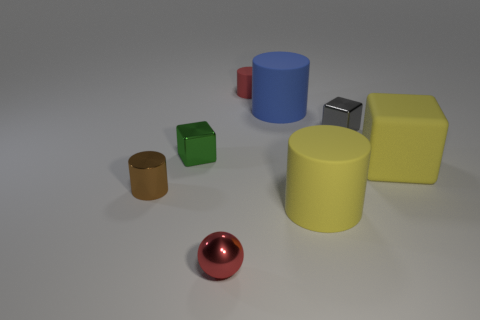Is there anything else that has the same shape as the tiny red shiny thing?
Offer a very short reply. No. There is a matte cylinder that is in front of the small gray metal object; does it have the same color as the large cube?
Your response must be concise. Yes. What number of objects are both in front of the green cube and to the left of the small metal ball?
Ensure brevity in your answer.  1. Does the red thing that is in front of the small rubber object have the same material as the green thing?
Ensure brevity in your answer.  Yes. What is the size of the yellow object that is in front of the small cylinder in front of the small red object that is behind the blue rubber cylinder?
Your response must be concise. Large. What number of other objects are there of the same color as the big matte block?
Provide a succinct answer. 1. There is another rubber thing that is the same size as the green object; what is its shape?
Provide a short and direct response. Cylinder. What is the size of the matte cylinder that is right of the blue thing?
Your answer should be very brief. Large. There is a small cylinder that is to the right of the small metallic sphere; does it have the same color as the small metal thing that is in front of the shiny cylinder?
Keep it short and to the point. Yes. What material is the red object in front of the object to the right of the tiny thing to the right of the blue matte cylinder?
Keep it short and to the point. Metal. 